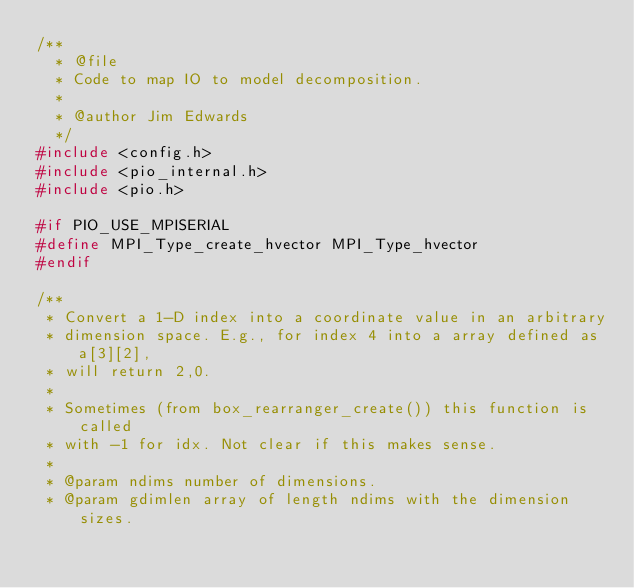<code> <loc_0><loc_0><loc_500><loc_500><_C_>/**
  * @file
  * Code to map IO to model decomposition.
  *
  * @author Jim Edwards
  */
#include <config.h>
#include <pio_internal.h>
#include <pio.h>

#if PIO_USE_MPISERIAL
#define MPI_Type_create_hvector MPI_Type_hvector
#endif

/**
 * Convert a 1-D index into a coordinate value in an arbitrary
 * dimension space. E.g., for index 4 into a array defined as a[3][2],
 * will return 2,0.
 *
 * Sometimes (from box_rearranger_create()) this function is called
 * with -1 for idx. Not clear if this makes sense.
 *
 * @param ndims number of dimensions.
 * @param gdimlen array of length ndims with the dimension sizes.</code> 